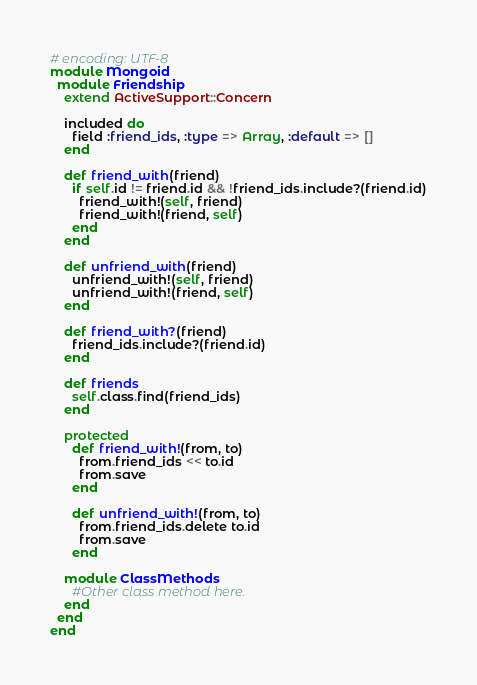<code> <loc_0><loc_0><loc_500><loc_500><_Ruby_># encoding: UTF-8
module Mongoid
  module Friendship
    extend ActiveSupport::Concern
    
    included do
      field :friend_ids, :type => Array, :default => []  
    end  
    
    def friend_with(friend)
      if self.id != friend.id && !friend_ids.include?(friend.id)
        friend_with!(self, friend)
        friend_with!(friend, self)
      end
    end

    def unfriend_with(friend)
      unfriend_with!(self, friend)
      unfriend_with!(friend, self)
    end

    def friend_with?(friend)
      friend_ids.include?(friend.id)
    end

    def friends
      self.class.find(friend_ids)
    end
    
    protected
      def friend_with!(from, to)
        from.friend_ids << to.id
        from.save
      end
      
      def unfriend_with!(from, to)
        from.friend_ids.delete to.id
        from.save
      end

    module ClassMethods  
      #Other class method here.      
    end  
  end
end</code> 